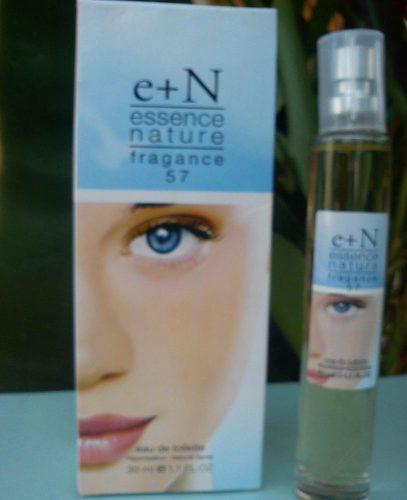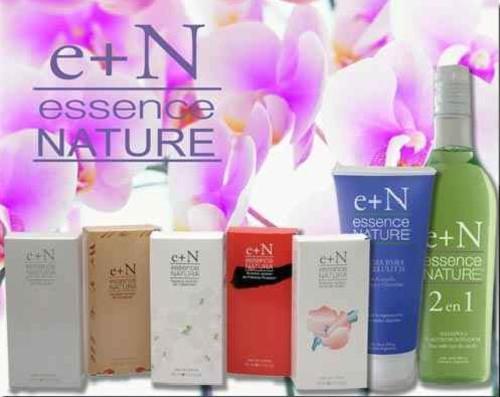The first image is the image on the left, the second image is the image on the right. Considering the images on both sides, is "One image shows a slender bottle upright next to a box with half of a woman's face on it's front." valid? Answer yes or no. Yes. 